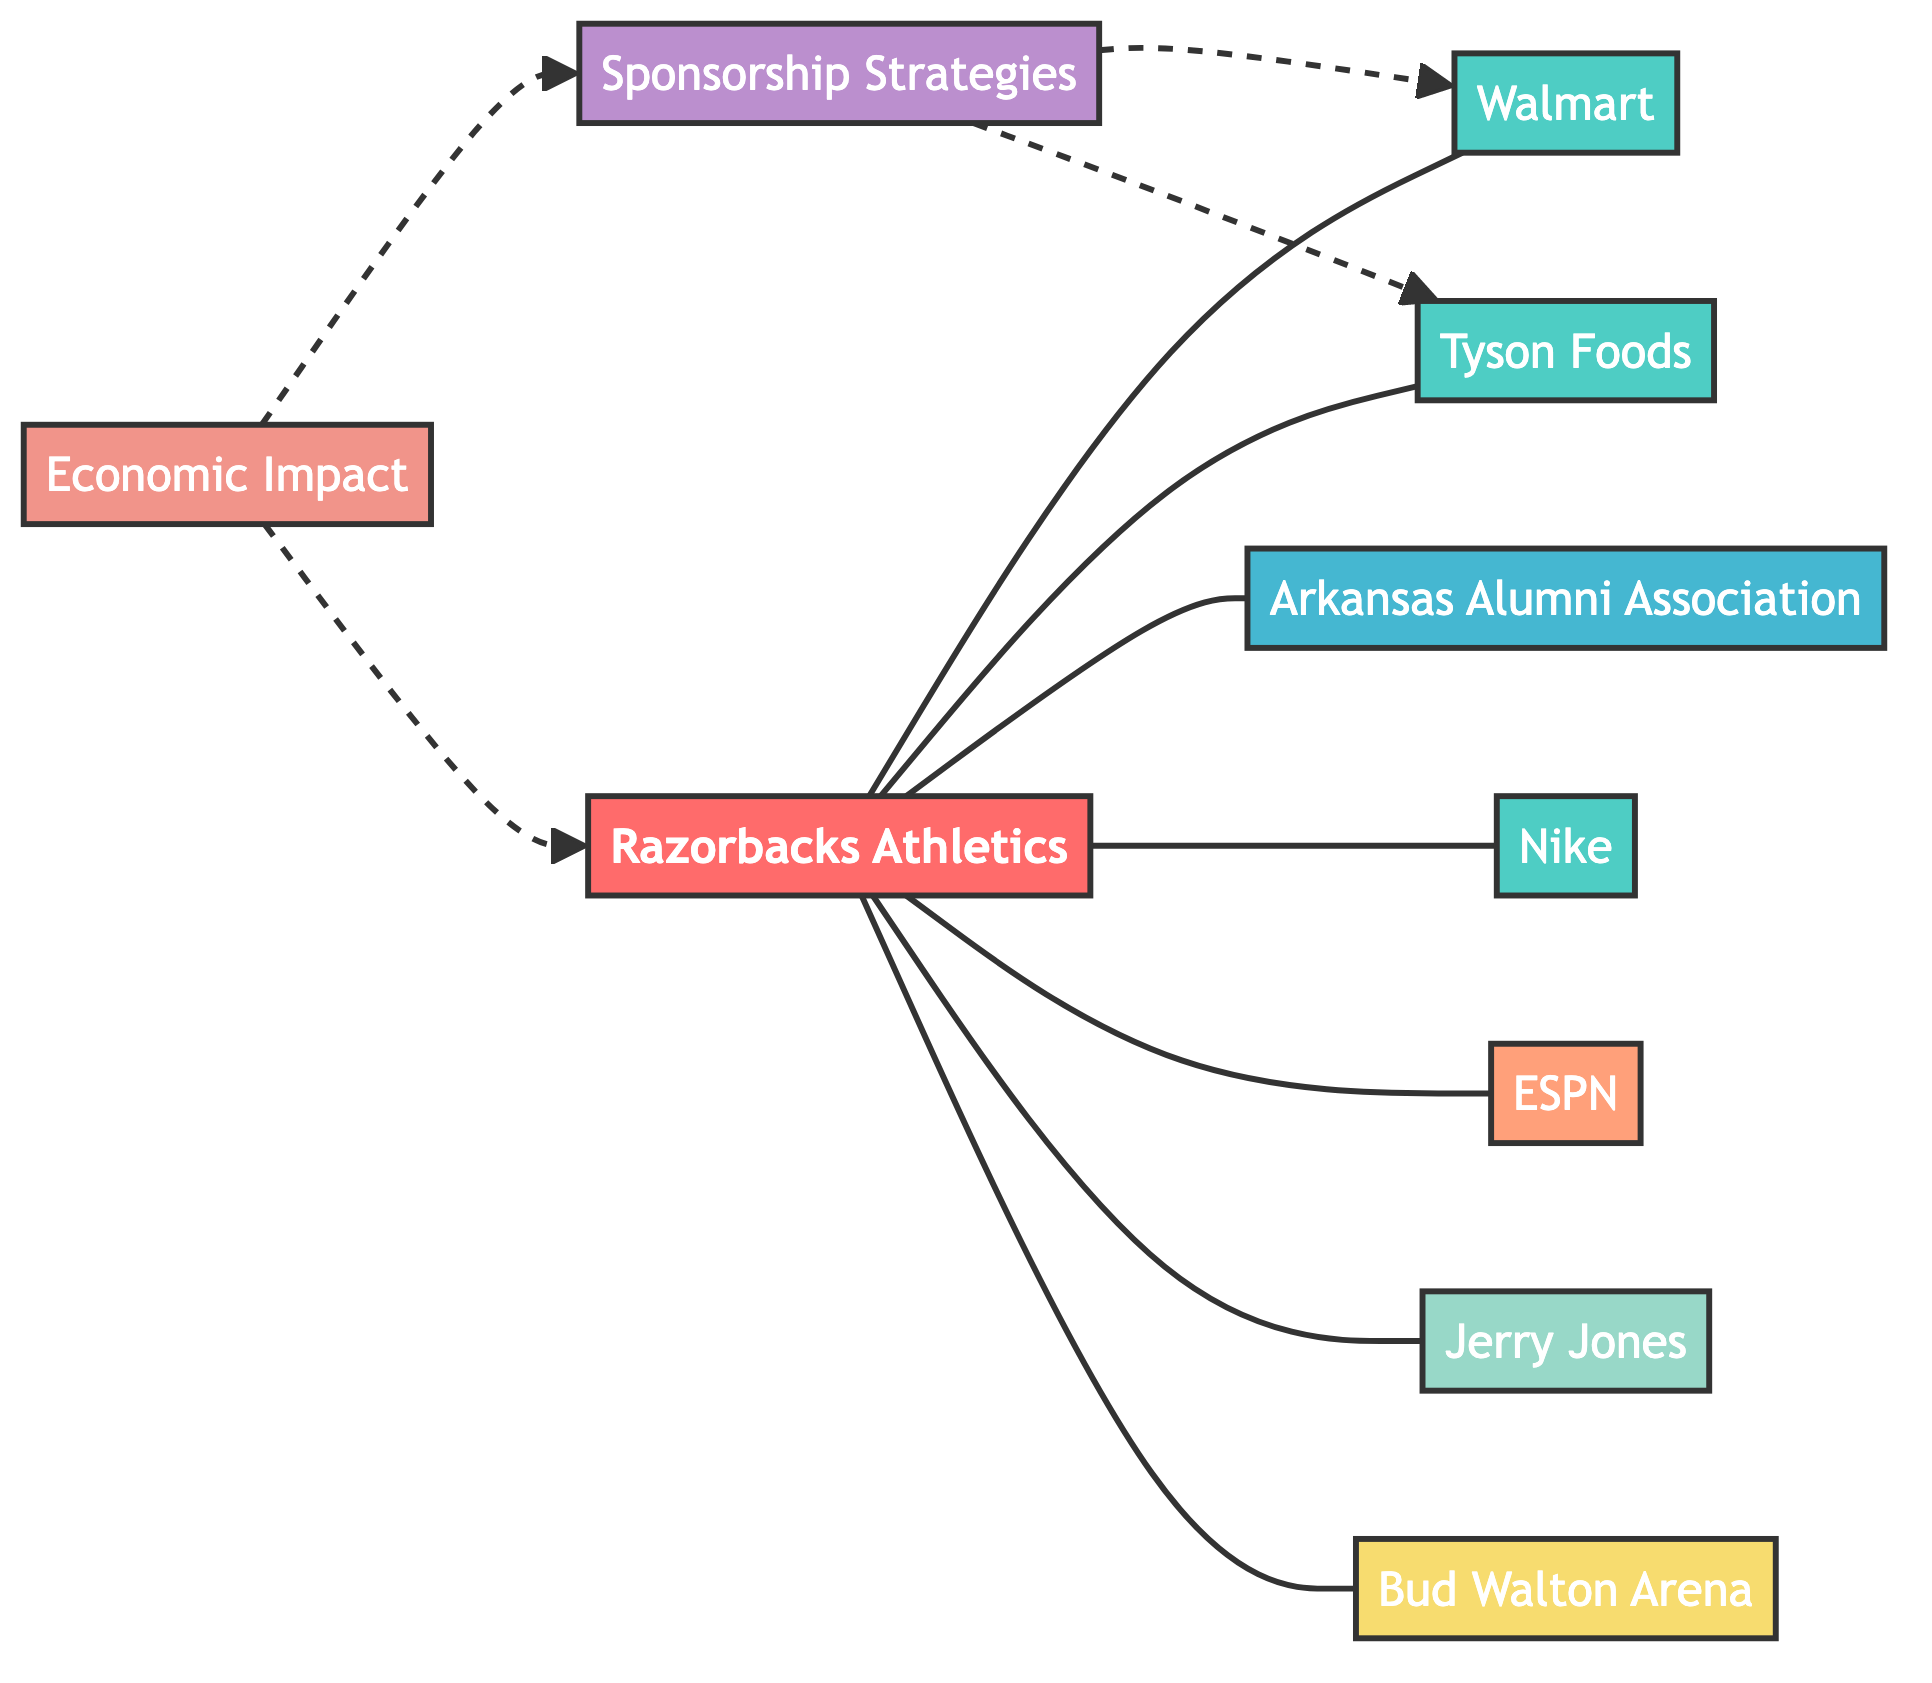What is the primary organization represented as a node in the diagram? The primary organization represented in the diagram is the Razorbacks Athletics, which is the central node from which other connections stem.
Answer: Razorbacks Athletics How many corporate sponsors are connected to the Razorbacks Athletics? By examining the links connected to the Razorbacks Athletics node, you can count that there are four corporate sponsors: Walmart, Tyson Foods, Nike, and Bud Walton Arena.
Answer: Four What type of relationship exists between Razorbacks Athletics and ESPN? The relationship between Razorbacks Athletics and ESPN is classified as a broadcasting connection, indicating that ESPN is a media partner specifically for broadcasting Razorbacks games.
Answer: Broadcasting Which node has the unique identifier 'JJ'? The unique identifier 'JJ' corresponds to Jerry Jones, who is marked as an individual donor with financial contributions to Razorbacks Athletics.
Answer: Jerry Jones How does Economic Impact relate to Sponsorship Strategies? Economic Impact is shown to have a dashed connection to Sponsorship Strategies, indicating that the Economic Impact is a result of implementing the various Sponsorship Strategies, thus highlighting the outcome of these strategies.
Answer: Result of Which corporation is associated with nutritional programs in Razorbacks Athletics? The corporation associated with nutritional programs in Razorbacks Athletics is Tyson Foods, as indicated by the specific link connecting them with the stated purpose.
Answer: Tyson Foods What type of node is Bud Walton Arena? Bud Walton Arena is categorized as a venue in the network diagram, which signifies its role in hosting Razorbacks events and serves as a significant sponsorship point.
Answer: Venue Which node has the most connections with Razorbacks Athletics? Razorbacks Athletics has the most connections with a total of seven links, representing its collaborations with various sponsors and contributors within the network.
Answer: Seven How do the strategies for sponsorship affect Razorbacks Athletics? The sponsorship strategies affect Razorbacks Athletics by providing various means of financial support and event promotion that contribute to the overall economic impact.
Answer: Affects 